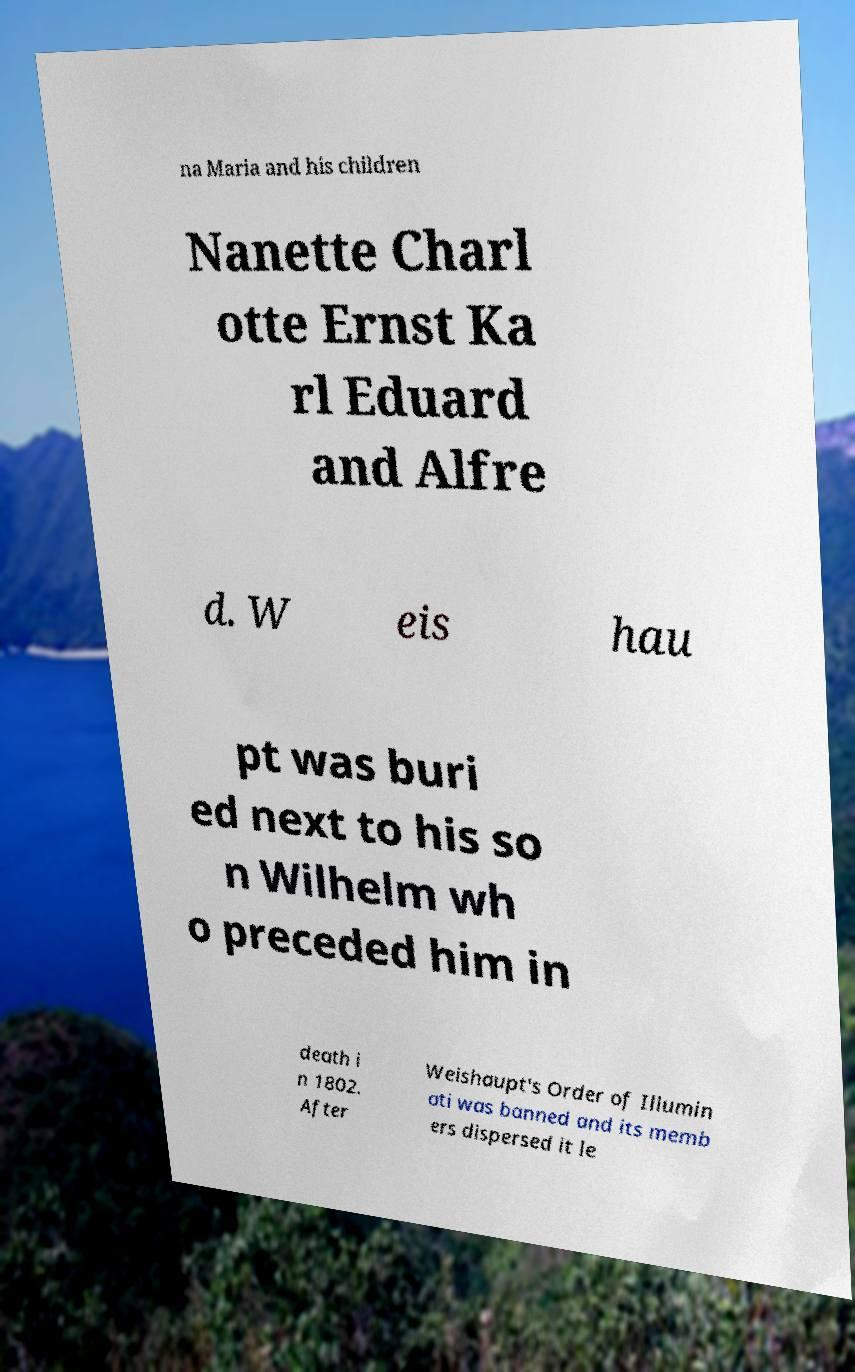I need the written content from this picture converted into text. Can you do that? na Maria and his children Nanette Charl otte Ernst Ka rl Eduard and Alfre d. W eis hau pt was buri ed next to his so n Wilhelm wh o preceded him in death i n 1802. After Weishaupt's Order of Illumin ati was banned and its memb ers dispersed it le 